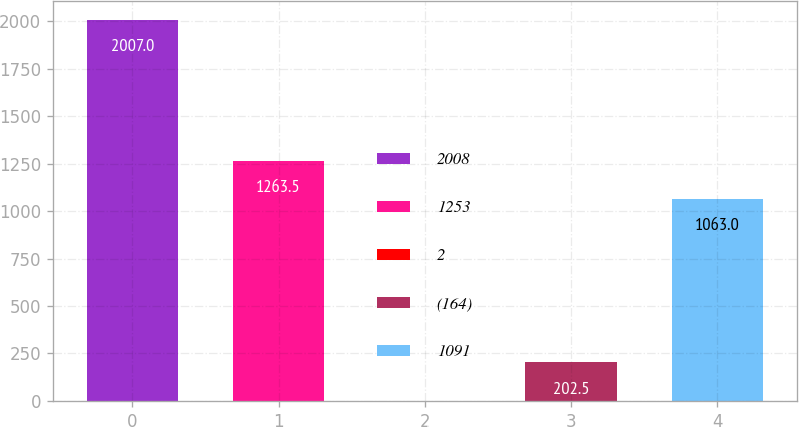Convert chart to OTSL. <chart><loc_0><loc_0><loc_500><loc_500><bar_chart><fcel>2008<fcel>1253<fcel>2<fcel>(164)<fcel>1091<nl><fcel>2007<fcel>1263.5<fcel>2<fcel>202.5<fcel>1063<nl></chart> 